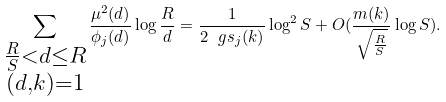<formula> <loc_0><loc_0><loc_500><loc_500>\sum _ { \substack { \frac { R } { S } < d \leq R \\ ( d , k ) = 1 } } \frac { \mu ^ { 2 } ( d ) } { \phi _ { j } ( d ) } \log \frac { R } { d } = \frac { 1 } { 2 \ g s _ { j } ( k ) } \log ^ { 2 } S + O ( \frac { m ( k ) } { \sqrt { \frac { R } { S } } } \log S ) .</formula> 